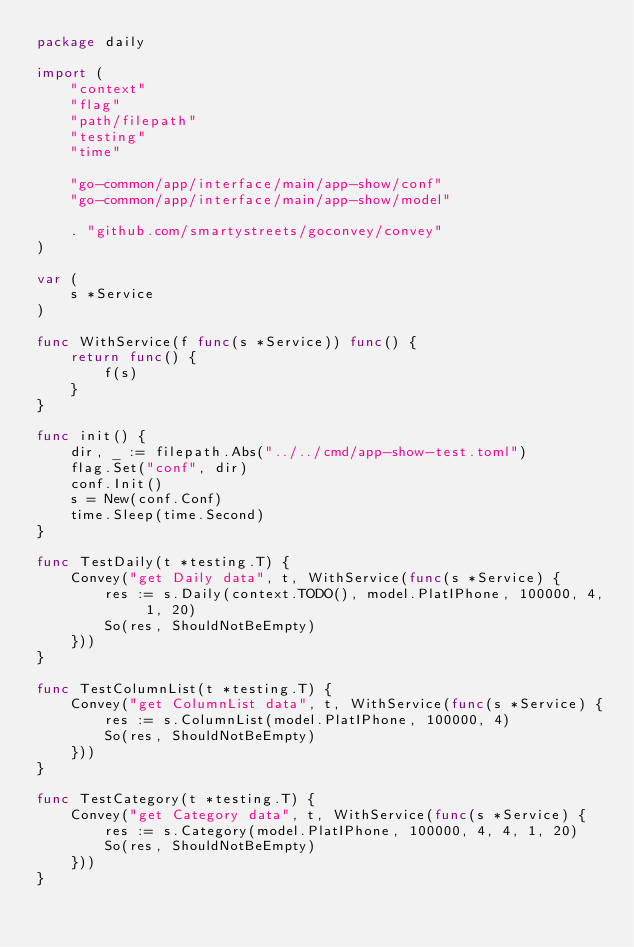<code> <loc_0><loc_0><loc_500><loc_500><_Go_>package daily

import (
	"context"
	"flag"
	"path/filepath"
	"testing"
	"time"

	"go-common/app/interface/main/app-show/conf"
	"go-common/app/interface/main/app-show/model"

	. "github.com/smartystreets/goconvey/convey"
)

var (
	s *Service
)

func WithService(f func(s *Service)) func() {
	return func() {
		f(s)
	}
}

func init() {
	dir, _ := filepath.Abs("../../cmd/app-show-test.toml")
	flag.Set("conf", dir)
	conf.Init()
	s = New(conf.Conf)
	time.Sleep(time.Second)
}

func TestDaily(t *testing.T) {
	Convey("get Daily data", t, WithService(func(s *Service) {
		res := s.Daily(context.TODO(), model.PlatIPhone, 100000, 4, 1, 20)
		So(res, ShouldNotBeEmpty)
	}))
}

func TestColumnList(t *testing.T) {
	Convey("get ColumnList data", t, WithService(func(s *Service) {
		res := s.ColumnList(model.PlatIPhone, 100000, 4)
		So(res, ShouldNotBeEmpty)
	}))
}

func TestCategory(t *testing.T) {
	Convey("get Category data", t, WithService(func(s *Service) {
		res := s.Category(model.PlatIPhone, 100000, 4, 4, 1, 20)
		So(res, ShouldNotBeEmpty)
	}))
}
</code> 